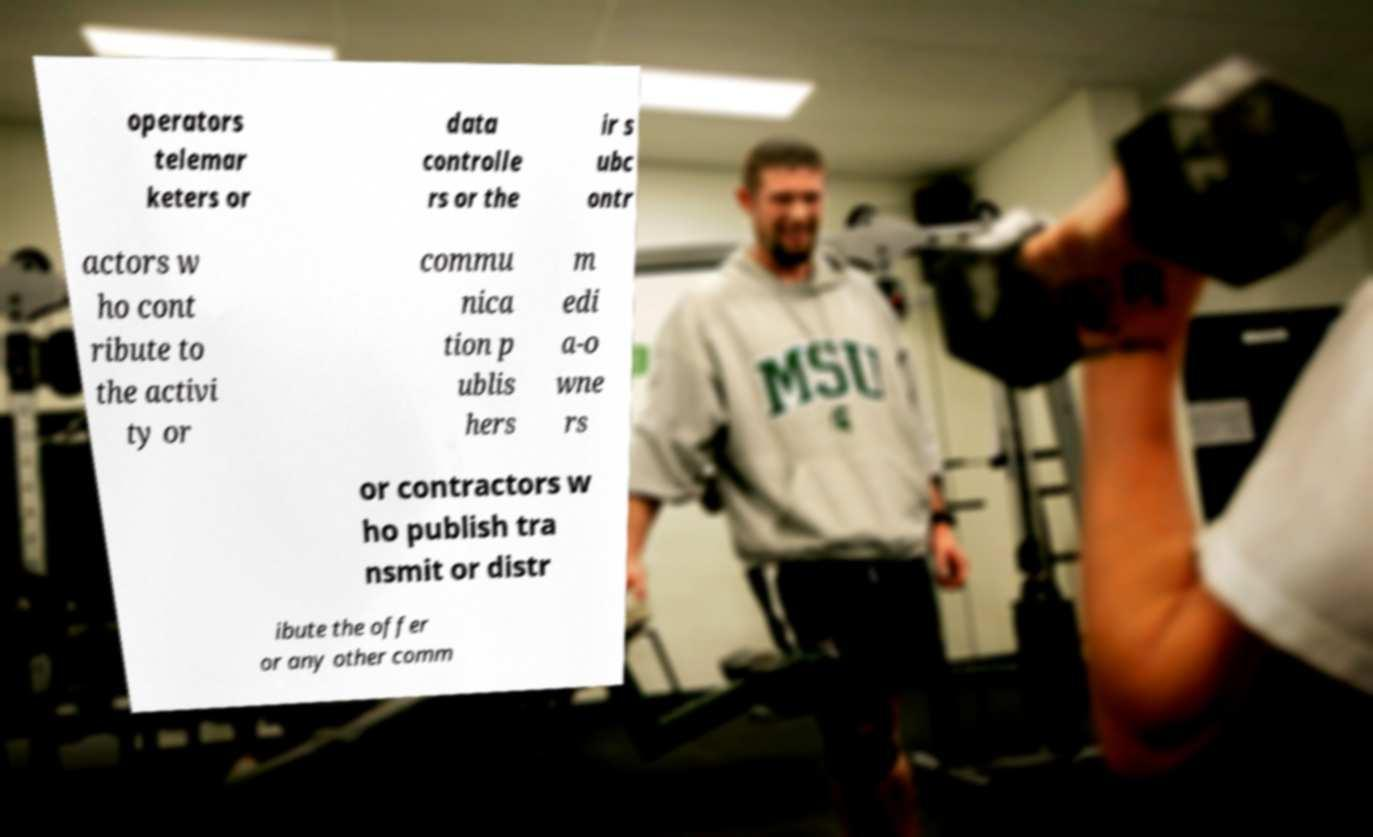Please read and relay the text visible in this image. What does it say? operators telemar keters or data controlle rs or the ir s ubc ontr actors w ho cont ribute to the activi ty or commu nica tion p ublis hers m edi a-o wne rs or contractors w ho publish tra nsmit or distr ibute the offer or any other comm 